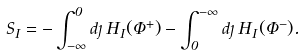<formula> <loc_0><loc_0><loc_500><loc_500>S _ { I } = - \int _ { - \infty } ^ { 0 } d \eta \, H _ { I } ( \Phi ^ { + } ) - \int _ { 0 } ^ { - \infty } d \eta \, H _ { I } ( \Phi ^ { - } ) .</formula> 